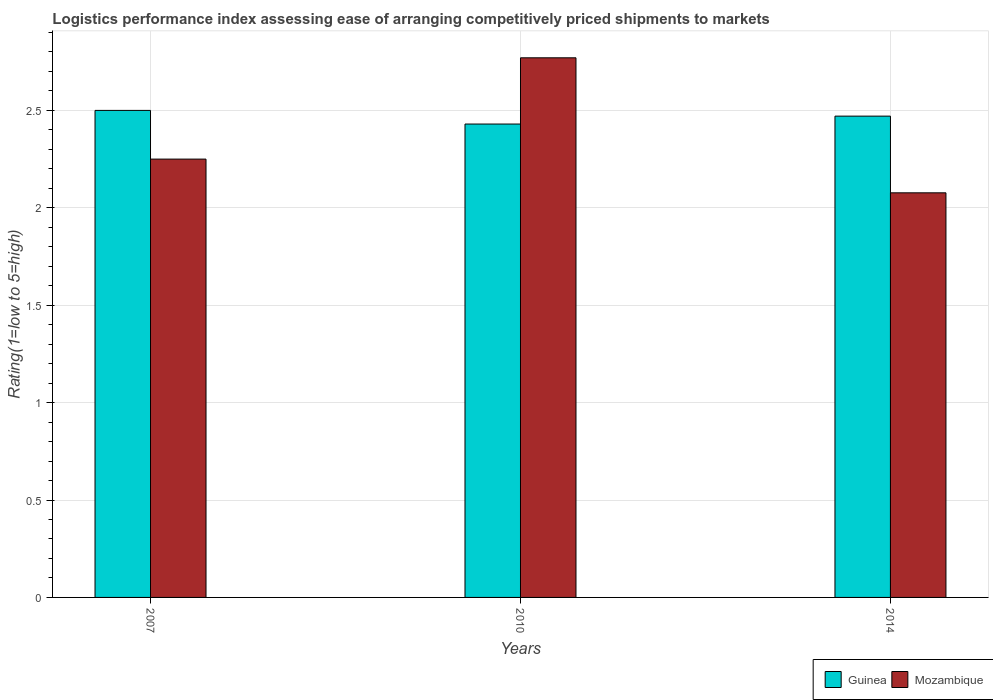How many groups of bars are there?
Make the answer very short. 3. How many bars are there on the 2nd tick from the left?
Your response must be concise. 2. How many bars are there on the 2nd tick from the right?
Give a very brief answer. 2. What is the label of the 1st group of bars from the left?
Your answer should be compact. 2007. What is the Logistic performance index in Guinea in 2014?
Your response must be concise. 2.47. Across all years, what is the maximum Logistic performance index in Mozambique?
Provide a short and direct response. 2.77. Across all years, what is the minimum Logistic performance index in Mozambique?
Make the answer very short. 2.08. What is the total Logistic performance index in Guinea in the graph?
Provide a succinct answer. 7.4. What is the difference between the Logistic performance index in Mozambique in 2007 and that in 2014?
Your response must be concise. 0.17. What is the difference between the Logistic performance index in Mozambique in 2007 and the Logistic performance index in Guinea in 2010?
Ensure brevity in your answer.  -0.18. What is the average Logistic performance index in Guinea per year?
Keep it short and to the point. 2.47. In the year 2010, what is the difference between the Logistic performance index in Mozambique and Logistic performance index in Guinea?
Offer a very short reply. 0.34. In how many years, is the Logistic performance index in Mozambique greater than 1.5?
Your response must be concise. 3. What is the ratio of the Logistic performance index in Guinea in 2007 to that in 2010?
Provide a short and direct response. 1.03. Is the difference between the Logistic performance index in Mozambique in 2010 and 2014 greater than the difference between the Logistic performance index in Guinea in 2010 and 2014?
Your answer should be very brief. Yes. What is the difference between the highest and the second highest Logistic performance index in Mozambique?
Keep it short and to the point. 0.52. What is the difference between the highest and the lowest Logistic performance index in Guinea?
Your response must be concise. 0.07. What does the 2nd bar from the left in 2007 represents?
Offer a terse response. Mozambique. What does the 2nd bar from the right in 2014 represents?
Your answer should be very brief. Guinea. How many bars are there?
Give a very brief answer. 6. Are all the bars in the graph horizontal?
Offer a very short reply. No. What is the difference between two consecutive major ticks on the Y-axis?
Your answer should be very brief. 0.5. Are the values on the major ticks of Y-axis written in scientific E-notation?
Provide a short and direct response. No. Does the graph contain any zero values?
Make the answer very short. No. Does the graph contain grids?
Your answer should be very brief. Yes. Where does the legend appear in the graph?
Your response must be concise. Bottom right. What is the title of the graph?
Provide a short and direct response. Logistics performance index assessing ease of arranging competitively priced shipments to markets. What is the label or title of the X-axis?
Offer a terse response. Years. What is the label or title of the Y-axis?
Keep it short and to the point. Rating(1=low to 5=high). What is the Rating(1=low to 5=high) in Mozambique in 2007?
Your answer should be very brief. 2.25. What is the Rating(1=low to 5=high) in Guinea in 2010?
Make the answer very short. 2.43. What is the Rating(1=low to 5=high) of Mozambique in 2010?
Make the answer very short. 2.77. What is the Rating(1=low to 5=high) of Guinea in 2014?
Give a very brief answer. 2.47. What is the Rating(1=low to 5=high) in Mozambique in 2014?
Your answer should be compact. 2.08. Across all years, what is the maximum Rating(1=low to 5=high) of Guinea?
Provide a succinct answer. 2.5. Across all years, what is the maximum Rating(1=low to 5=high) in Mozambique?
Keep it short and to the point. 2.77. Across all years, what is the minimum Rating(1=low to 5=high) in Guinea?
Your answer should be very brief. 2.43. Across all years, what is the minimum Rating(1=low to 5=high) of Mozambique?
Your answer should be very brief. 2.08. What is the total Rating(1=low to 5=high) of Guinea in the graph?
Ensure brevity in your answer.  7.4. What is the total Rating(1=low to 5=high) of Mozambique in the graph?
Make the answer very short. 7.1. What is the difference between the Rating(1=low to 5=high) in Guinea in 2007 and that in 2010?
Provide a short and direct response. 0.07. What is the difference between the Rating(1=low to 5=high) in Mozambique in 2007 and that in 2010?
Your answer should be compact. -0.52. What is the difference between the Rating(1=low to 5=high) of Guinea in 2007 and that in 2014?
Ensure brevity in your answer.  0.03. What is the difference between the Rating(1=low to 5=high) in Mozambique in 2007 and that in 2014?
Your response must be concise. 0.17. What is the difference between the Rating(1=low to 5=high) in Guinea in 2010 and that in 2014?
Make the answer very short. -0.04. What is the difference between the Rating(1=low to 5=high) of Mozambique in 2010 and that in 2014?
Provide a succinct answer. 0.69. What is the difference between the Rating(1=low to 5=high) in Guinea in 2007 and the Rating(1=low to 5=high) in Mozambique in 2010?
Keep it short and to the point. -0.27. What is the difference between the Rating(1=low to 5=high) of Guinea in 2007 and the Rating(1=low to 5=high) of Mozambique in 2014?
Ensure brevity in your answer.  0.42. What is the difference between the Rating(1=low to 5=high) in Guinea in 2010 and the Rating(1=low to 5=high) in Mozambique in 2014?
Offer a very short reply. 0.35. What is the average Rating(1=low to 5=high) in Guinea per year?
Offer a very short reply. 2.47. What is the average Rating(1=low to 5=high) of Mozambique per year?
Provide a short and direct response. 2.37. In the year 2007, what is the difference between the Rating(1=low to 5=high) of Guinea and Rating(1=low to 5=high) of Mozambique?
Ensure brevity in your answer.  0.25. In the year 2010, what is the difference between the Rating(1=low to 5=high) in Guinea and Rating(1=low to 5=high) in Mozambique?
Provide a short and direct response. -0.34. In the year 2014, what is the difference between the Rating(1=low to 5=high) in Guinea and Rating(1=low to 5=high) in Mozambique?
Your answer should be very brief. 0.39. What is the ratio of the Rating(1=low to 5=high) of Guinea in 2007 to that in 2010?
Keep it short and to the point. 1.03. What is the ratio of the Rating(1=low to 5=high) of Mozambique in 2007 to that in 2010?
Make the answer very short. 0.81. What is the ratio of the Rating(1=low to 5=high) of Guinea in 2007 to that in 2014?
Give a very brief answer. 1.01. What is the ratio of the Rating(1=low to 5=high) in Mozambique in 2007 to that in 2014?
Your response must be concise. 1.08. What is the ratio of the Rating(1=low to 5=high) in Guinea in 2010 to that in 2014?
Offer a very short reply. 0.98. What is the ratio of the Rating(1=low to 5=high) in Mozambique in 2010 to that in 2014?
Keep it short and to the point. 1.33. What is the difference between the highest and the second highest Rating(1=low to 5=high) of Guinea?
Keep it short and to the point. 0.03. What is the difference between the highest and the second highest Rating(1=low to 5=high) of Mozambique?
Give a very brief answer. 0.52. What is the difference between the highest and the lowest Rating(1=low to 5=high) in Guinea?
Ensure brevity in your answer.  0.07. What is the difference between the highest and the lowest Rating(1=low to 5=high) of Mozambique?
Your response must be concise. 0.69. 